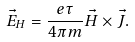<formula> <loc_0><loc_0><loc_500><loc_500>\vec { E } _ { H } = \frac { e \tau } { 4 \pi m } \vec { H } \times \vec { J } .</formula> 